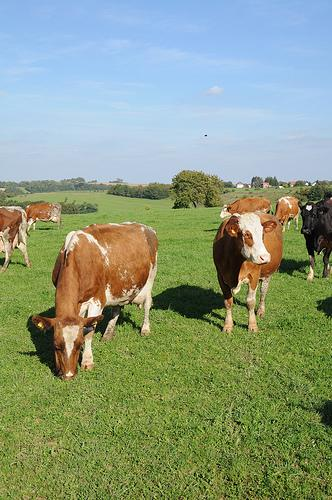Summarize the image in one sentence involving the main subject. The picture captures a brown and white cow peacefully grazing in a lush, green field under a bright, sunny sky. Provide a brief overview of the image by highlighting the key elements in the scene. The photo showcases a herd of mostly brown and white cattle grazing on green grass, with blue skies, a few clouds, trees, and distant buildings. Describe the scenery in the image as if it was the setting for a novel. On a verdant expanse of land, a small gathering of brown and white cows grazed in harmony, set against the serene backdrop of blue skies, soft clouds, and distant, otherworldly structures. Portray the image from the viewpoint of one of the cows. Today, I enjoyed grazing on green grass in the company of my fellow cows while basking under the warm sunlight and observing the surrounding trees and distant buildings. Explain the primary focus of the picture, including the dominant colors present. The image primarily features a brown and white cow with a white face, grazing on short, green grass with other cattle in the field. Utilize poetic language to describe the essence of the image. A pastoral symphony of brown and white cows, softly grazing on verdant meadows beneath an azure sky sprinkled with wisps of white clouds. Narrate the image as if you are telling a story to a child. Once upon a time, in a beautiful field, there was a lovely cow with a white face, grazing alongside her friends among green grass under a cheerful blue sky. Imagine you are a tour guide, briefly describing the image to your group. Ladies and gentlemen, here we have a pristine pasture featuring brown and white cattle grazing on vibrant green grass, surrounded by a serene landscape of trees and distant buildings. Describe the image as if you are speaking to someone who cannot see it. The image displays a brown and white cow grazing in a field of green grass, accompanied by other cattle, with blue skies, fluffy clouds, trees, and faraway buildings in the background. Write a news headline that conveys the main subject of the image. Local Brown and White Cows Enjoy Tranquil Grazing in Picturesque Countryside 